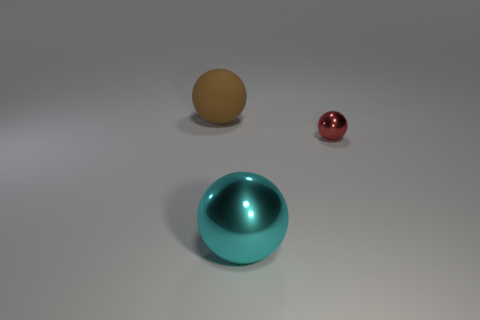Is the number of balls behind the big brown thing less than the number of large matte balls?
Make the answer very short. Yes. Does the big shiny sphere have the same color as the small thing?
Your answer should be very brief. No. What is the size of the brown thing?
Your answer should be compact. Large. What number of objects have the same color as the rubber ball?
Provide a short and direct response. 0. Is there a brown matte sphere that is on the left side of the red metal sphere that is on the right side of the metal ball that is in front of the red metallic object?
Provide a short and direct response. Yes. What number of tiny things are matte balls or metal spheres?
Your answer should be very brief. 1. There is a big thing that is the same material as the small red thing; what is its color?
Offer a very short reply. Cyan. Do the object to the right of the large cyan metallic sphere and the object left of the large cyan thing have the same shape?
Provide a succinct answer. Yes. What number of metallic objects are big brown objects or big yellow spheres?
Offer a terse response. 0. What is the ball that is right of the large cyan thing made of?
Offer a terse response. Metal. 